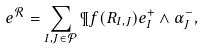<formula> <loc_0><loc_0><loc_500><loc_500>e ^ { \mathcal { R } } = \sum _ { I , J \in \mathcal { P } } \P f ( R _ { I , J } ) e ^ { + } _ { I } \wedge \alpha ^ { - } _ { J } ,</formula> 